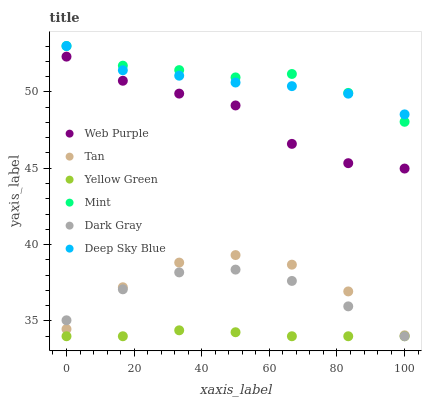Does Yellow Green have the minimum area under the curve?
Answer yes or no. Yes. Does Mint have the maximum area under the curve?
Answer yes or no. Yes. Does Dark Gray have the minimum area under the curve?
Answer yes or no. No. Does Dark Gray have the maximum area under the curve?
Answer yes or no. No. Is Yellow Green the smoothest?
Answer yes or no. Yes. Is Tan the roughest?
Answer yes or no. Yes. Is Dark Gray the smoothest?
Answer yes or no. No. Is Dark Gray the roughest?
Answer yes or no. No. Does Yellow Green have the lowest value?
Answer yes or no. Yes. Does Web Purple have the lowest value?
Answer yes or no. No. Does Mint have the highest value?
Answer yes or no. Yes. Does Dark Gray have the highest value?
Answer yes or no. No. Is Yellow Green less than Mint?
Answer yes or no. Yes. Is Mint greater than Tan?
Answer yes or no. Yes. Does Deep Sky Blue intersect Mint?
Answer yes or no. Yes. Is Deep Sky Blue less than Mint?
Answer yes or no. No. Is Deep Sky Blue greater than Mint?
Answer yes or no. No. Does Yellow Green intersect Mint?
Answer yes or no. No. 